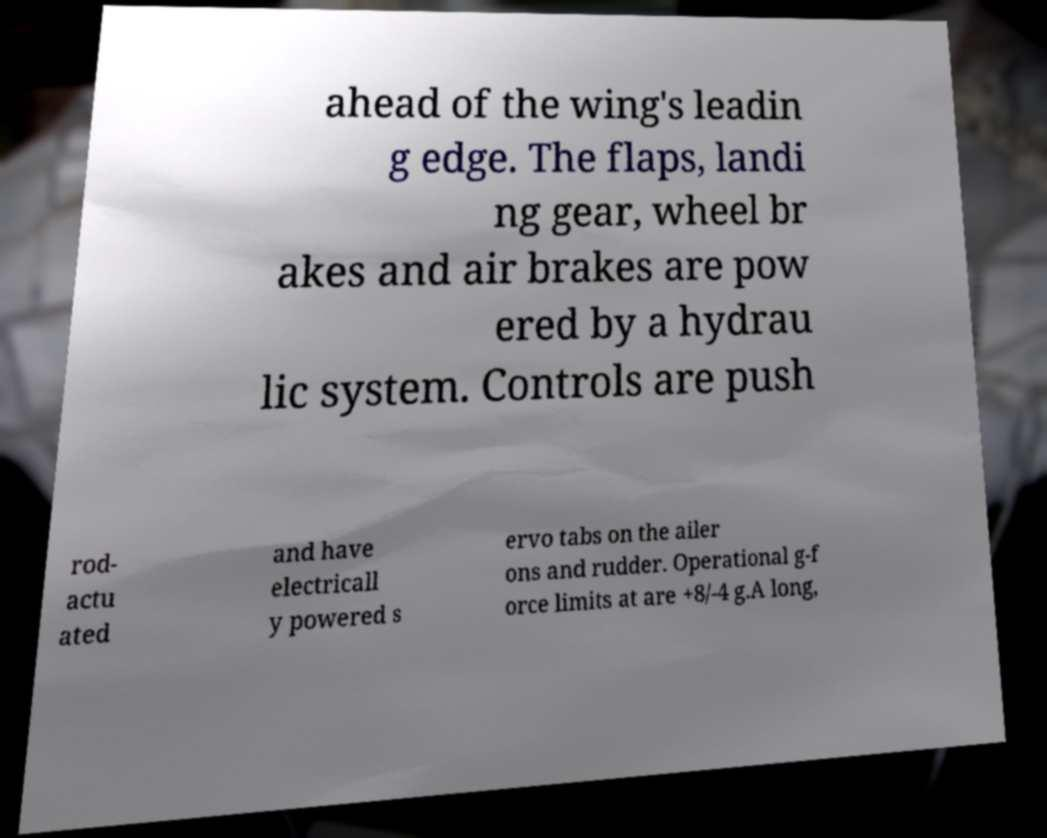There's text embedded in this image that I need extracted. Can you transcribe it verbatim? ahead of the wing's leadin g edge. The flaps, landi ng gear, wheel br akes and air brakes are pow ered by a hydrau lic system. Controls are push rod- actu ated and have electricall y powered s ervo tabs on the ailer ons and rudder. Operational g-f orce limits at are +8/-4 g.A long, 